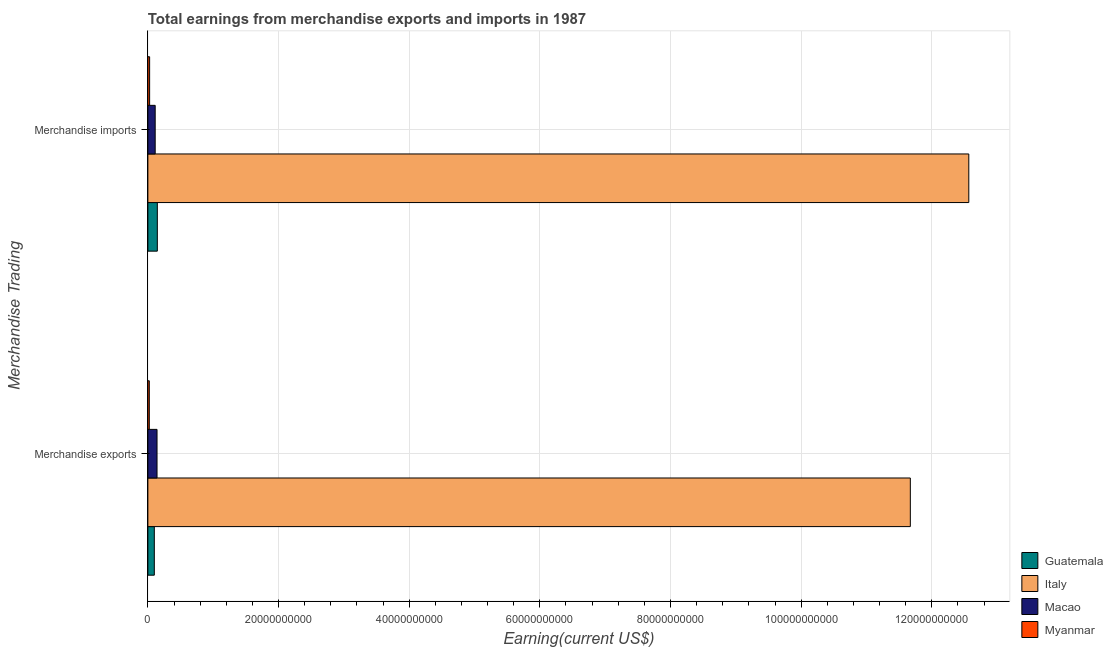How many different coloured bars are there?
Keep it short and to the point. 4. How many groups of bars are there?
Keep it short and to the point. 2. Are the number of bars per tick equal to the number of legend labels?
Give a very brief answer. Yes. What is the earnings from merchandise imports in Guatemala?
Your answer should be very brief. 1.45e+09. Across all countries, what is the maximum earnings from merchandise imports?
Offer a very short reply. 1.26e+11. Across all countries, what is the minimum earnings from merchandise exports?
Keep it short and to the point. 2.19e+08. In which country was the earnings from merchandise imports maximum?
Provide a succinct answer. Italy. In which country was the earnings from merchandise exports minimum?
Your answer should be compact. Myanmar. What is the total earnings from merchandise imports in the graph?
Keep it short and to the point. 1.28e+11. What is the difference between the earnings from merchandise exports in Italy and that in Myanmar?
Give a very brief answer. 1.16e+11. What is the difference between the earnings from merchandise imports in Macao and the earnings from merchandise exports in Italy?
Give a very brief answer. -1.16e+11. What is the average earnings from merchandise imports per country?
Make the answer very short. 3.21e+1. What is the difference between the earnings from merchandise imports and earnings from merchandise exports in Macao?
Make the answer very short. -2.82e+08. In how many countries, is the earnings from merchandise imports greater than 20000000000 US$?
Offer a very short reply. 1. What is the ratio of the earnings from merchandise exports in Italy to that in Myanmar?
Offer a very short reply. 532.93. Is the earnings from merchandise imports in Macao less than that in Italy?
Offer a terse response. Yes. In how many countries, is the earnings from merchandise imports greater than the average earnings from merchandise imports taken over all countries?
Ensure brevity in your answer.  1. What does the 2nd bar from the top in Merchandise exports represents?
Provide a short and direct response. Macao. What does the 4th bar from the bottom in Merchandise imports represents?
Offer a very short reply. Myanmar. How many countries are there in the graph?
Make the answer very short. 4. Does the graph contain any zero values?
Provide a succinct answer. No. Where does the legend appear in the graph?
Make the answer very short. Bottom right. How many legend labels are there?
Give a very brief answer. 4. What is the title of the graph?
Provide a succinct answer. Total earnings from merchandise exports and imports in 1987. What is the label or title of the X-axis?
Offer a terse response. Earning(current US$). What is the label or title of the Y-axis?
Offer a terse response. Merchandise Trading. What is the Earning(current US$) in Guatemala in Merchandise exports?
Give a very brief answer. 9.87e+08. What is the Earning(current US$) in Italy in Merchandise exports?
Keep it short and to the point. 1.17e+11. What is the Earning(current US$) in Macao in Merchandise exports?
Offer a very short reply. 1.40e+09. What is the Earning(current US$) in Myanmar in Merchandise exports?
Keep it short and to the point. 2.19e+08. What is the Earning(current US$) of Guatemala in Merchandise imports?
Your answer should be compact. 1.45e+09. What is the Earning(current US$) of Italy in Merchandise imports?
Offer a terse response. 1.26e+11. What is the Earning(current US$) in Macao in Merchandise imports?
Make the answer very short. 1.12e+09. What is the Earning(current US$) in Myanmar in Merchandise imports?
Your answer should be very brief. 2.68e+08. Across all Merchandise Trading, what is the maximum Earning(current US$) in Guatemala?
Give a very brief answer. 1.45e+09. Across all Merchandise Trading, what is the maximum Earning(current US$) in Italy?
Your answer should be compact. 1.26e+11. Across all Merchandise Trading, what is the maximum Earning(current US$) in Macao?
Give a very brief answer. 1.40e+09. Across all Merchandise Trading, what is the maximum Earning(current US$) of Myanmar?
Give a very brief answer. 2.68e+08. Across all Merchandise Trading, what is the minimum Earning(current US$) in Guatemala?
Your answer should be very brief. 9.87e+08. Across all Merchandise Trading, what is the minimum Earning(current US$) of Italy?
Offer a terse response. 1.17e+11. Across all Merchandise Trading, what is the minimum Earning(current US$) in Macao?
Offer a terse response. 1.12e+09. Across all Merchandise Trading, what is the minimum Earning(current US$) of Myanmar?
Give a very brief answer. 2.19e+08. What is the total Earning(current US$) of Guatemala in the graph?
Make the answer very short. 2.43e+09. What is the total Earning(current US$) of Italy in the graph?
Offer a terse response. 2.42e+11. What is the total Earning(current US$) of Macao in the graph?
Ensure brevity in your answer.  2.52e+09. What is the total Earning(current US$) in Myanmar in the graph?
Your response must be concise. 4.87e+08. What is the difference between the Earning(current US$) of Guatemala in Merchandise exports and that in Merchandise imports?
Your answer should be very brief. -4.60e+08. What is the difference between the Earning(current US$) of Italy in Merchandise exports and that in Merchandise imports?
Your response must be concise. -8.95e+09. What is the difference between the Earning(current US$) in Macao in Merchandise exports and that in Merchandise imports?
Ensure brevity in your answer.  2.82e+08. What is the difference between the Earning(current US$) in Myanmar in Merchandise exports and that in Merchandise imports?
Offer a terse response. -4.90e+07. What is the difference between the Earning(current US$) in Guatemala in Merchandise exports and the Earning(current US$) in Italy in Merchandise imports?
Your answer should be compact. -1.25e+11. What is the difference between the Earning(current US$) in Guatemala in Merchandise exports and the Earning(current US$) in Macao in Merchandise imports?
Keep it short and to the point. -1.33e+08. What is the difference between the Earning(current US$) of Guatemala in Merchandise exports and the Earning(current US$) of Myanmar in Merchandise imports?
Offer a very short reply. 7.19e+08. What is the difference between the Earning(current US$) of Italy in Merchandise exports and the Earning(current US$) of Macao in Merchandise imports?
Your response must be concise. 1.16e+11. What is the difference between the Earning(current US$) of Italy in Merchandise exports and the Earning(current US$) of Myanmar in Merchandise imports?
Your response must be concise. 1.16e+11. What is the difference between the Earning(current US$) of Macao in Merchandise exports and the Earning(current US$) of Myanmar in Merchandise imports?
Ensure brevity in your answer.  1.13e+09. What is the average Earning(current US$) of Guatemala per Merchandise Trading?
Your answer should be compact. 1.22e+09. What is the average Earning(current US$) of Italy per Merchandise Trading?
Your response must be concise. 1.21e+11. What is the average Earning(current US$) in Macao per Merchandise Trading?
Your answer should be compact. 1.26e+09. What is the average Earning(current US$) in Myanmar per Merchandise Trading?
Offer a very short reply. 2.44e+08. What is the difference between the Earning(current US$) of Guatemala and Earning(current US$) of Italy in Merchandise exports?
Ensure brevity in your answer.  -1.16e+11. What is the difference between the Earning(current US$) of Guatemala and Earning(current US$) of Macao in Merchandise exports?
Provide a short and direct response. -4.15e+08. What is the difference between the Earning(current US$) in Guatemala and Earning(current US$) in Myanmar in Merchandise exports?
Give a very brief answer. 7.68e+08. What is the difference between the Earning(current US$) in Italy and Earning(current US$) in Macao in Merchandise exports?
Your answer should be very brief. 1.15e+11. What is the difference between the Earning(current US$) of Italy and Earning(current US$) of Myanmar in Merchandise exports?
Ensure brevity in your answer.  1.16e+11. What is the difference between the Earning(current US$) in Macao and Earning(current US$) in Myanmar in Merchandise exports?
Your answer should be very brief. 1.18e+09. What is the difference between the Earning(current US$) in Guatemala and Earning(current US$) in Italy in Merchandise imports?
Provide a succinct answer. -1.24e+11. What is the difference between the Earning(current US$) in Guatemala and Earning(current US$) in Macao in Merchandise imports?
Provide a short and direct response. 3.27e+08. What is the difference between the Earning(current US$) of Guatemala and Earning(current US$) of Myanmar in Merchandise imports?
Make the answer very short. 1.18e+09. What is the difference between the Earning(current US$) of Italy and Earning(current US$) of Macao in Merchandise imports?
Offer a terse response. 1.25e+11. What is the difference between the Earning(current US$) of Italy and Earning(current US$) of Myanmar in Merchandise imports?
Your answer should be compact. 1.25e+11. What is the difference between the Earning(current US$) of Macao and Earning(current US$) of Myanmar in Merchandise imports?
Give a very brief answer. 8.52e+08. What is the ratio of the Earning(current US$) of Guatemala in Merchandise exports to that in Merchandise imports?
Offer a terse response. 0.68. What is the ratio of the Earning(current US$) in Italy in Merchandise exports to that in Merchandise imports?
Provide a short and direct response. 0.93. What is the ratio of the Earning(current US$) of Macao in Merchandise exports to that in Merchandise imports?
Provide a short and direct response. 1.25. What is the ratio of the Earning(current US$) in Myanmar in Merchandise exports to that in Merchandise imports?
Offer a very short reply. 0.82. What is the difference between the highest and the second highest Earning(current US$) in Guatemala?
Make the answer very short. 4.60e+08. What is the difference between the highest and the second highest Earning(current US$) of Italy?
Ensure brevity in your answer.  8.95e+09. What is the difference between the highest and the second highest Earning(current US$) in Macao?
Give a very brief answer. 2.82e+08. What is the difference between the highest and the second highest Earning(current US$) in Myanmar?
Offer a very short reply. 4.90e+07. What is the difference between the highest and the lowest Earning(current US$) of Guatemala?
Make the answer very short. 4.60e+08. What is the difference between the highest and the lowest Earning(current US$) of Italy?
Your answer should be very brief. 8.95e+09. What is the difference between the highest and the lowest Earning(current US$) in Macao?
Offer a very short reply. 2.82e+08. What is the difference between the highest and the lowest Earning(current US$) in Myanmar?
Give a very brief answer. 4.90e+07. 